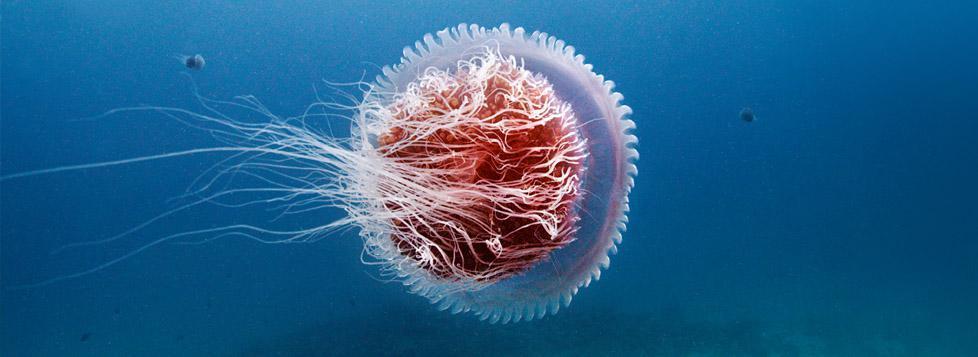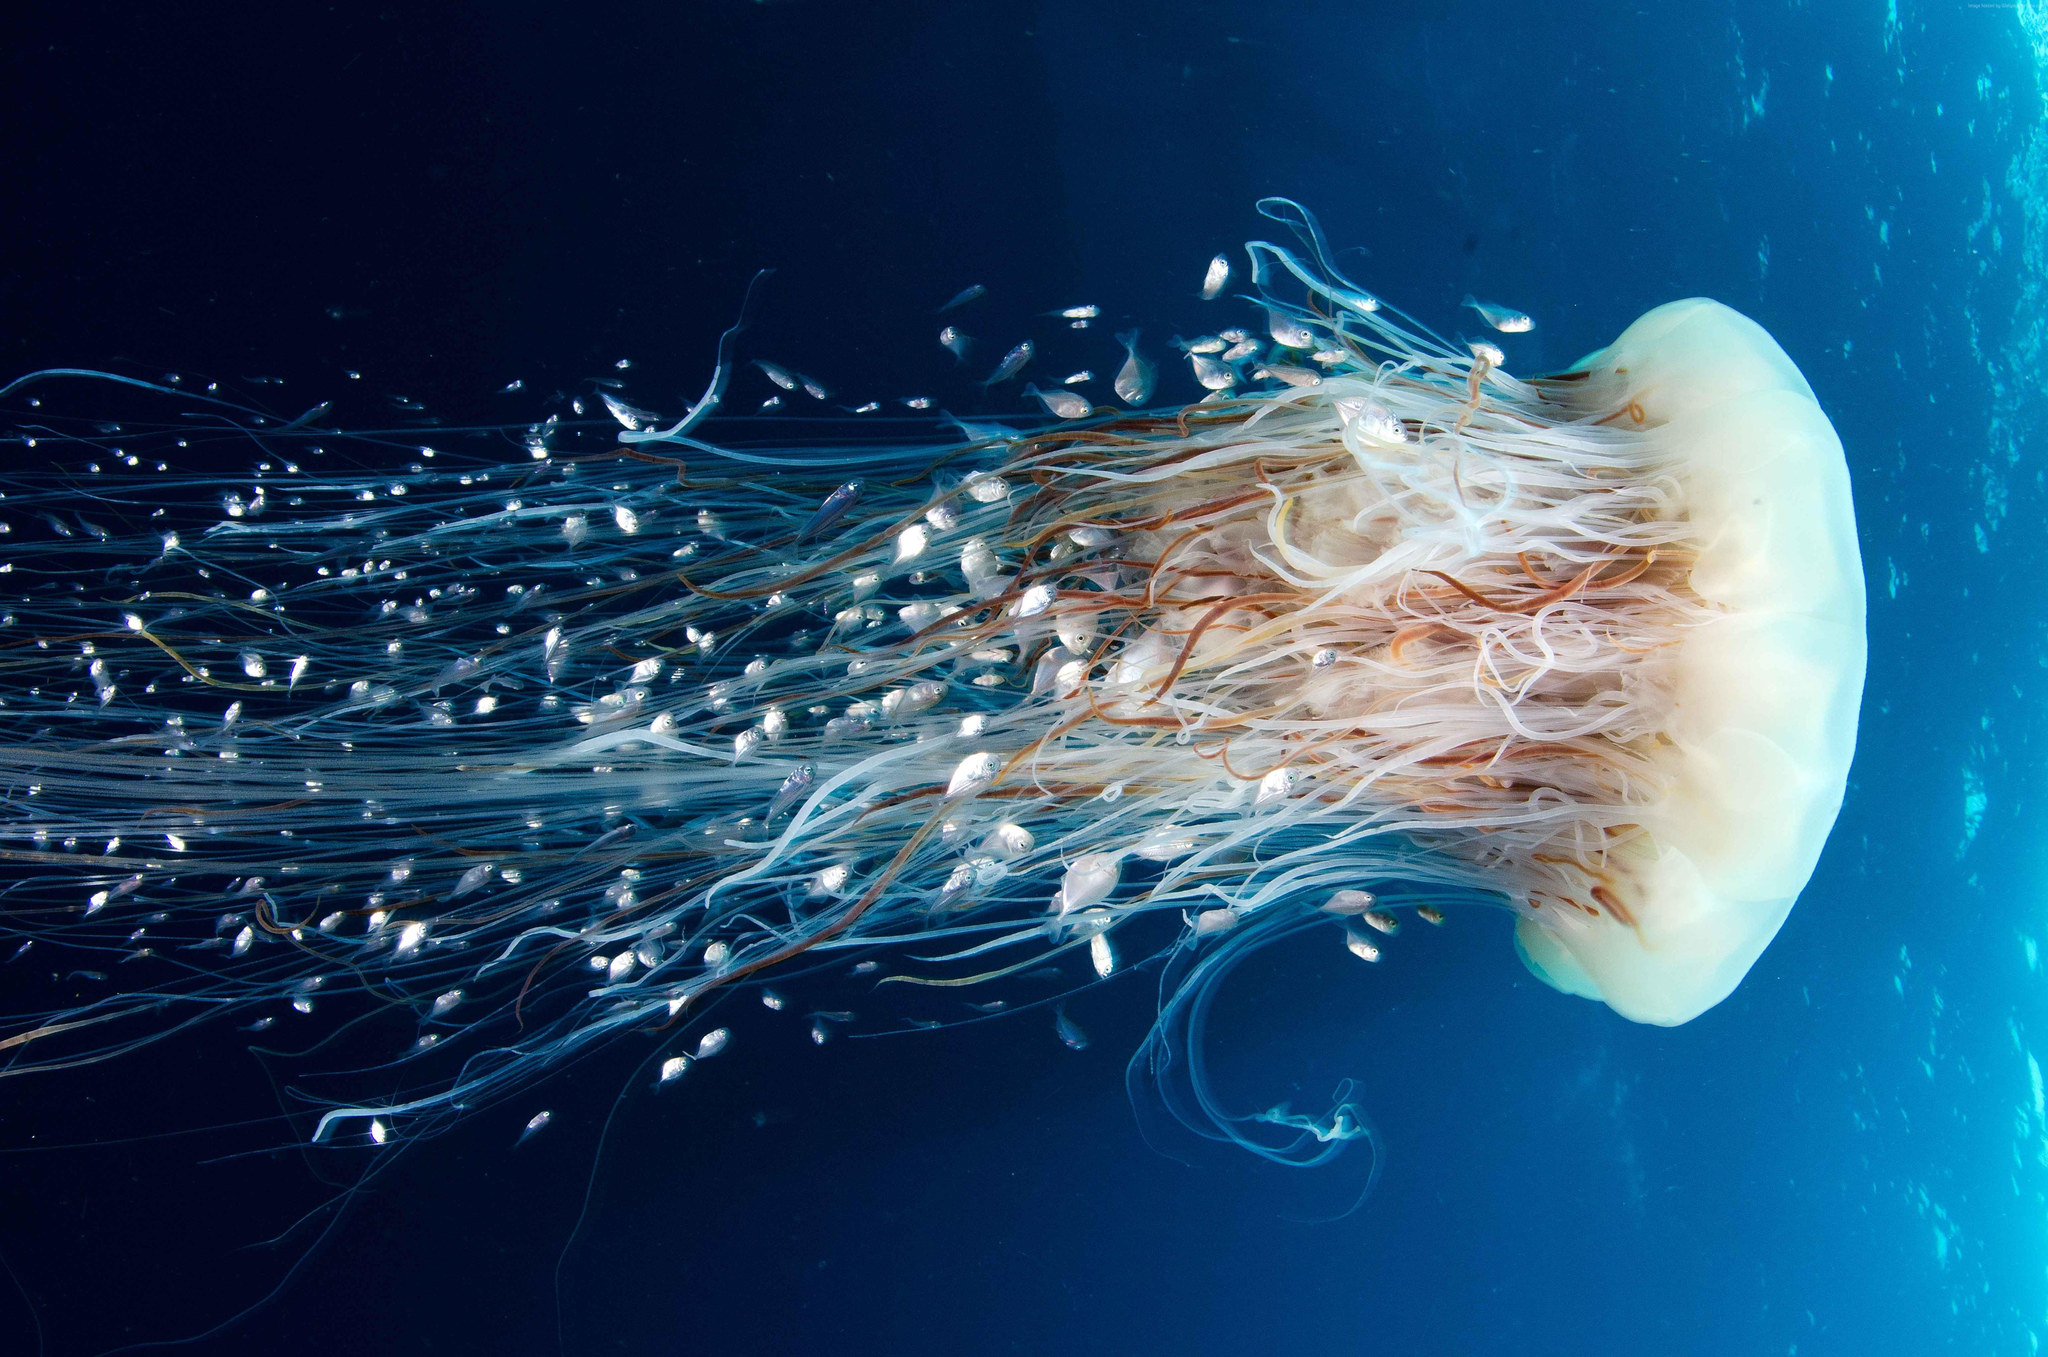The first image is the image on the left, the second image is the image on the right. Examine the images to the left and right. Is the description "there is a single jellyfish swimming to the right" accurate? Answer yes or no. Yes. The first image is the image on the left, the second image is the image on the right. Assess this claim about the two images: "Each image contains exactly one jellyfish, and one image shows a jellyfish with its 'cap' turned rightward and its long tentacles trailing horizontally to the left.". Correct or not? Answer yes or no. Yes. 